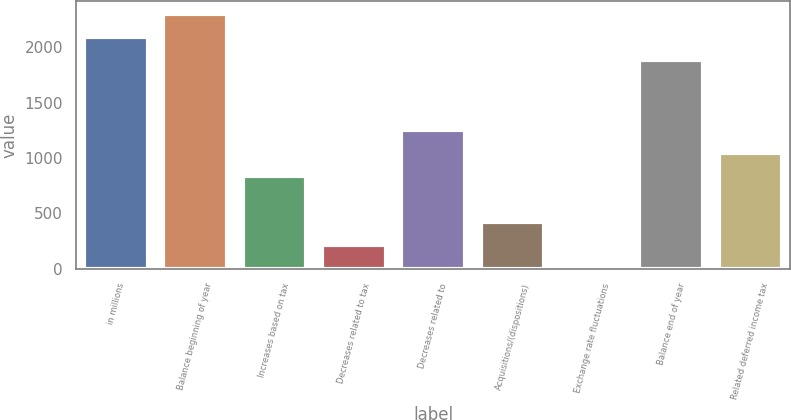Convert chart to OTSL. <chart><loc_0><loc_0><loc_500><loc_500><bar_chart><fcel>in millions<fcel>Balance beginning of year<fcel>Increases based on tax<fcel>Decreases related to tax<fcel>Decreases related to<fcel>Acquisitions/(dispositions)<fcel>Exchange rate fluctuations<fcel>Balance end of year<fcel>Related deferred income tax<nl><fcel>2094<fcel>2301<fcel>839<fcel>218<fcel>1253<fcel>425<fcel>11<fcel>1887<fcel>1046<nl></chart> 